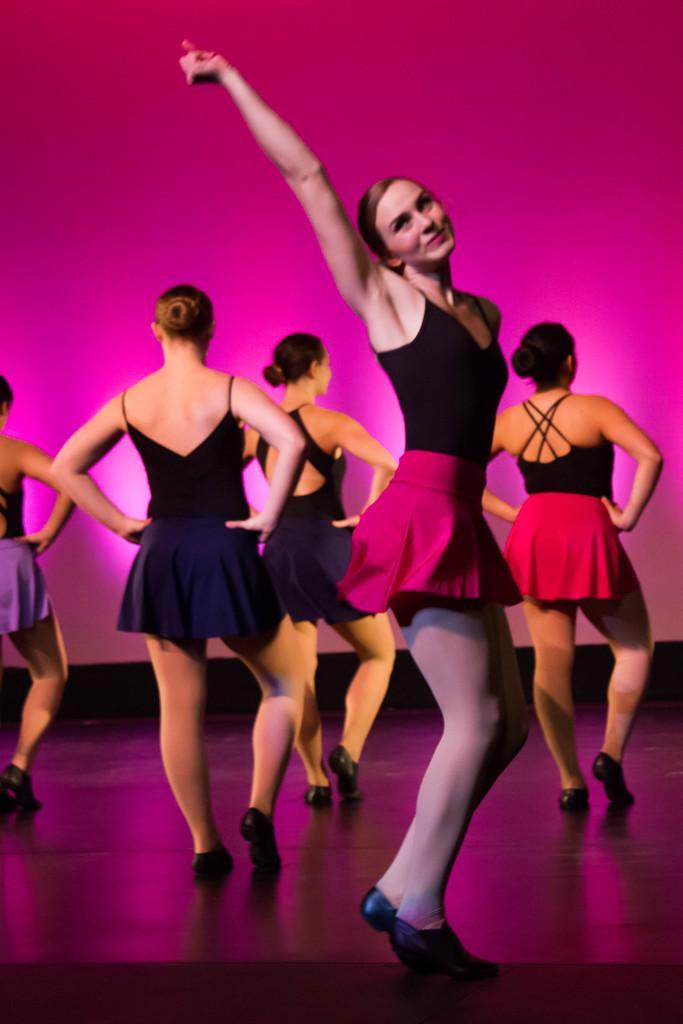Could you give a brief overview of what you see in this image? In this image I can see a woman wearing black and pink colored dress is standing on the floor and in the background I can see few other woman wearing dresses and footwear are standing and the pink colored surface. 